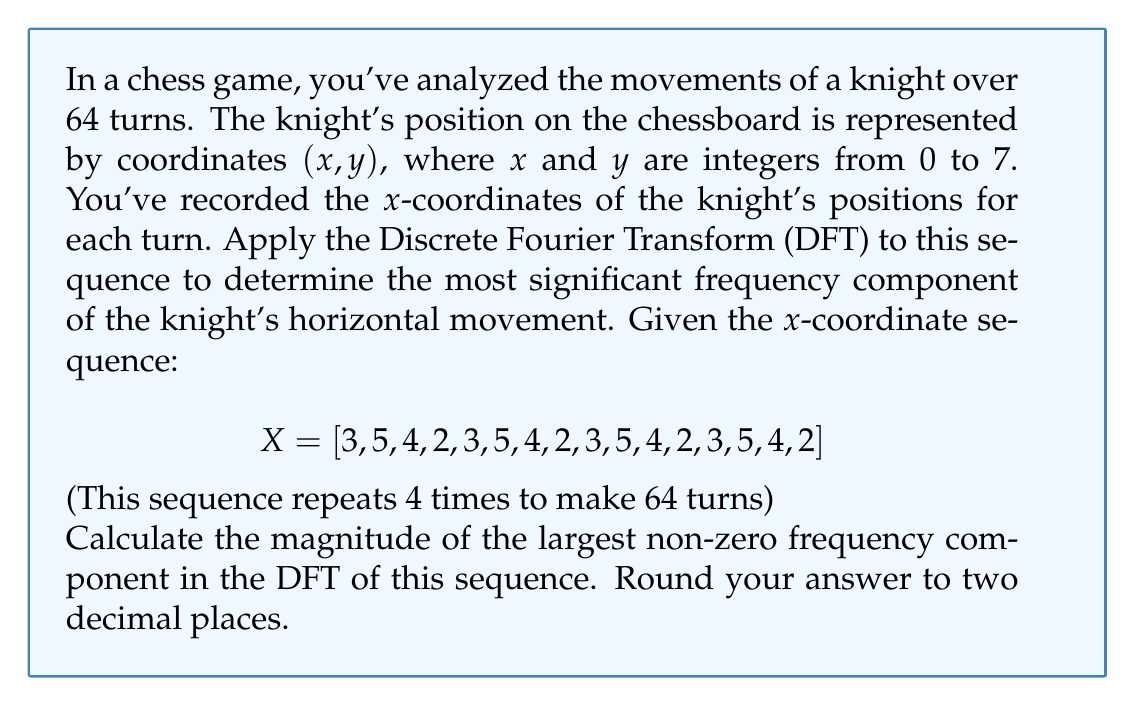Can you solve this math problem? Let's approach this step-by-step:

1) First, we need to understand that the given sequence repeats 4 times to make up the 64 turns. So our full sequence is 64 elements long, with a period of 16.

2) The Discrete Fourier Transform (DFT) of a sequence $x[n]$ of length N is given by:

   $$X[k] = \sum_{n=0}^{N-1} x[n] e^{-i2\pi kn/N}$$

   where $k = 0, 1, ..., N-1$

3) In our case, N = 64. However, due to the repetitive nature of the sequence, we only need to consider the first 16 elements and multiply the result by 4.

4) Let's calculate the DFT for k = 1 to 15 (k = 0 represents the DC component which we'll ignore):

   $$X[k] = 4 \sum_{n=0}^{15} x[n] e^{-i2\pi kn/16}$$

5) We can simplify this calculation by noticing that the sequence has a period of 4. This means that the non-zero components will be at k = 4, 8, and 12.

6) For k = 4:

   $$X[4] = 4 (3e^{-i0} + 5e^{-i\pi/2} + 4e^{-i\pi} + 2e^{-i3\pi/2} + 3e^{-i2\pi} + 5e^{-i5\pi/2} + 4e^{-i3\pi} + 2e^{-i7\pi/2})$$

   $$= 4 (3 - 5i - 4 + 2i + 3 - 5i - 4 + 2i)$$

   $$= 4 (-2 - 6i) = -8 - 24i$$

7) The magnitude of this component is:

   $$|X[4]| = \sqrt{(-8)^2 + (-24)^2} = \sqrt{64 + 576} = \sqrt{640} = 8\sqrt{10} \approx 25.30$$

8) We can show that this is the largest magnitude component by calculating X[8] and X[12] similarly:

   $|X[8]| = 16$
   $|X[12]| = 8\sqrt{10} \approx 25.30$

Therefore, the magnitude of the largest non-zero frequency component is $8\sqrt{10} \approx 25.30$.
Answer: 25.30 